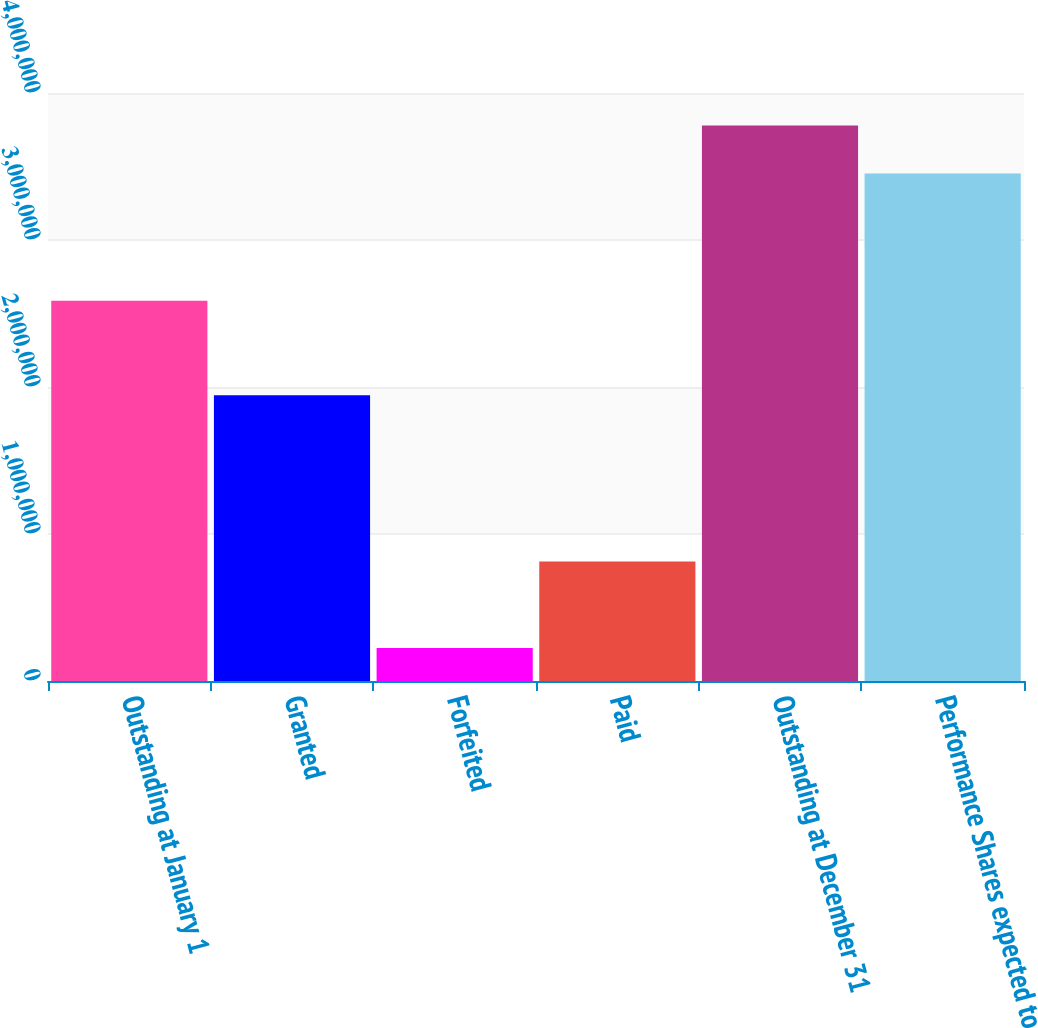<chart> <loc_0><loc_0><loc_500><loc_500><bar_chart><fcel>Outstanding at January 1<fcel>Granted<fcel>Forfeited<fcel>Paid<fcel>Outstanding at December 31<fcel>Performance Shares expected to<nl><fcel>2.58665e+06<fcel>1.9443e+06<fcel>224538<fcel>812975<fcel>3.77892e+06<fcel>3.45203e+06<nl></chart> 